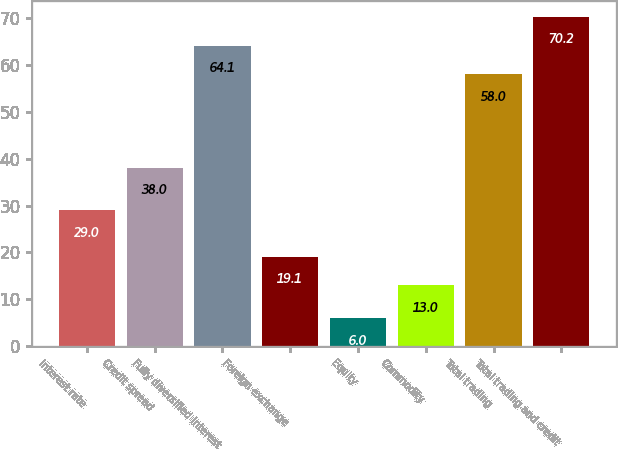Convert chart to OTSL. <chart><loc_0><loc_0><loc_500><loc_500><bar_chart><fcel>Interest rate<fcel>Credit spread<fcel>Fully diversified interest<fcel>Foreign exchange<fcel>Equity<fcel>Commodity<fcel>Total trading<fcel>Total trading and credit<nl><fcel>29<fcel>38<fcel>64.1<fcel>19.1<fcel>6<fcel>13<fcel>58<fcel>70.2<nl></chart> 